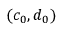<formula> <loc_0><loc_0><loc_500><loc_500>( c _ { 0 } , d _ { 0 } )</formula> 